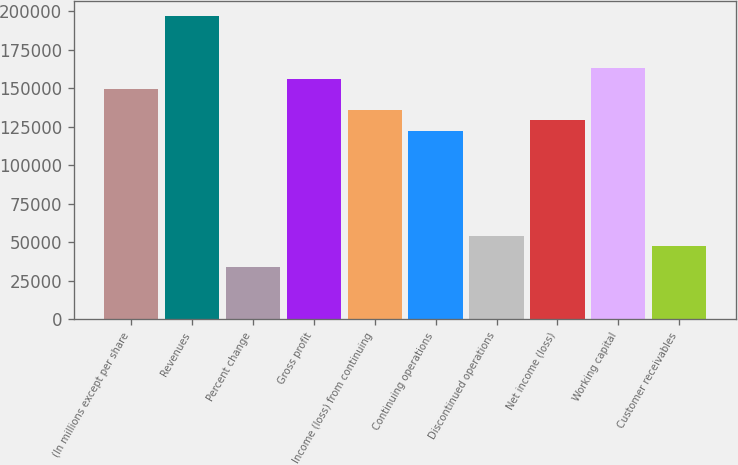<chart> <loc_0><loc_0><loc_500><loc_500><bar_chart><fcel>(In millions except per share<fcel>Revenues<fcel>Percent change<fcel>Gross profit<fcel>Income (loss) from continuing<fcel>Continuing operations<fcel>Discontinued operations<fcel>Net income (loss)<fcel>Working capital<fcel>Customer receivables<nl><fcel>149584<fcel>197179<fcel>33996.6<fcel>156384<fcel>135986<fcel>122387<fcel>54394.5<fcel>129187<fcel>163183<fcel>47595.2<nl></chart> 